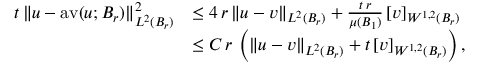Convert formula to latex. <formula><loc_0><loc_0><loc_500><loc_500>\begin{array} { r l } { t \, \| u - a v ( u ; B _ { r } ) \| _ { L ^ { 2 } ( B _ { r } ) } ^ { 2 } } & { \leq 4 \, r \, \| u - v \| _ { L ^ { 2 } ( B _ { r } ) } + \frac { t \, r } { \mu ( B _ { 1 } ) } \, [ v ] _ { W ^ { 1 , 2 } ( B _ { r } ) } } \\ & { \leq C \, r \, \left ( \| u - v \| _ { L ^ { 2 } ( B _ { r } ) } + t \, [ v ] _ { W ^ { 1 , 2 } ( B _ { r } ) } \right ) , } \end{array}</formula> 